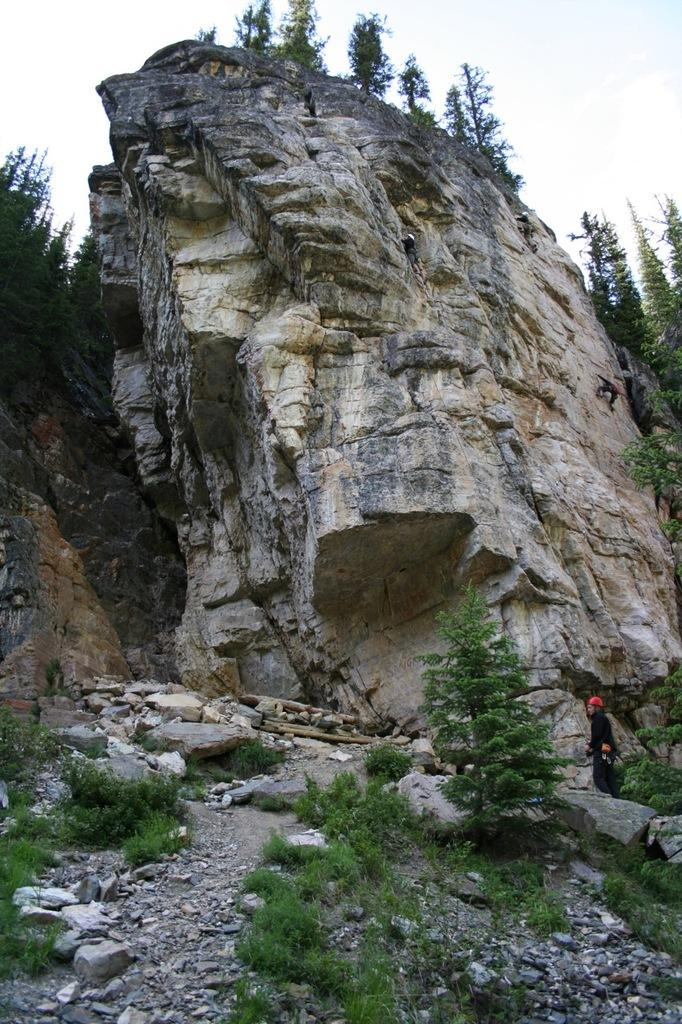What is the main subject in the image? There is a person standing in the image. What type of natural elements can be seen in the image? There are plants, trees, and rocks in the image. What are the people doing in the image? People are climbing on the rocks. What type of work is the person doing on top of the rocks in the image? There is no indication of work being done in the image, as the person is simply standing on the rocks. Additionally, there is no mention of the person being on top of the rocks. 